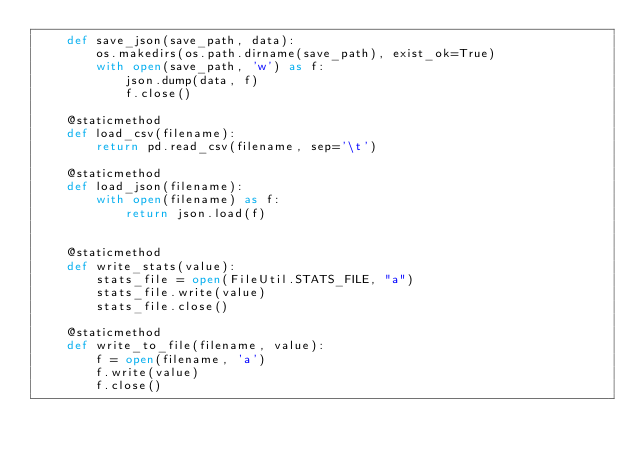<code> <loc_0><loc_0><loc_500><loc_500><_Python_>    def save_json(save_path, data):
        os.makedirs(os.path.dirname(save_path), exist_ok=True)
        with open(save_path, 'w') as f:
            json.dump(data, f)
            f.close()

    @staticmethod
    def load_csv(filename):
        return pd.read_csv(filename, sep='\t')

    @staticmethod
    def load_json(filename):
        with open(filename) as f:
            return json.load(f)


    @staticmethod
    def write_stats(value):
        stats_file = open(FileUtil.STATS_FILE, "a")
        stats_file.write(value)
        stats_file.close()

    @staticmethod
    def write_to_file(filename, value):
        f = open(filename, 'a')
        f.write(value)
        f.close()
</code> 